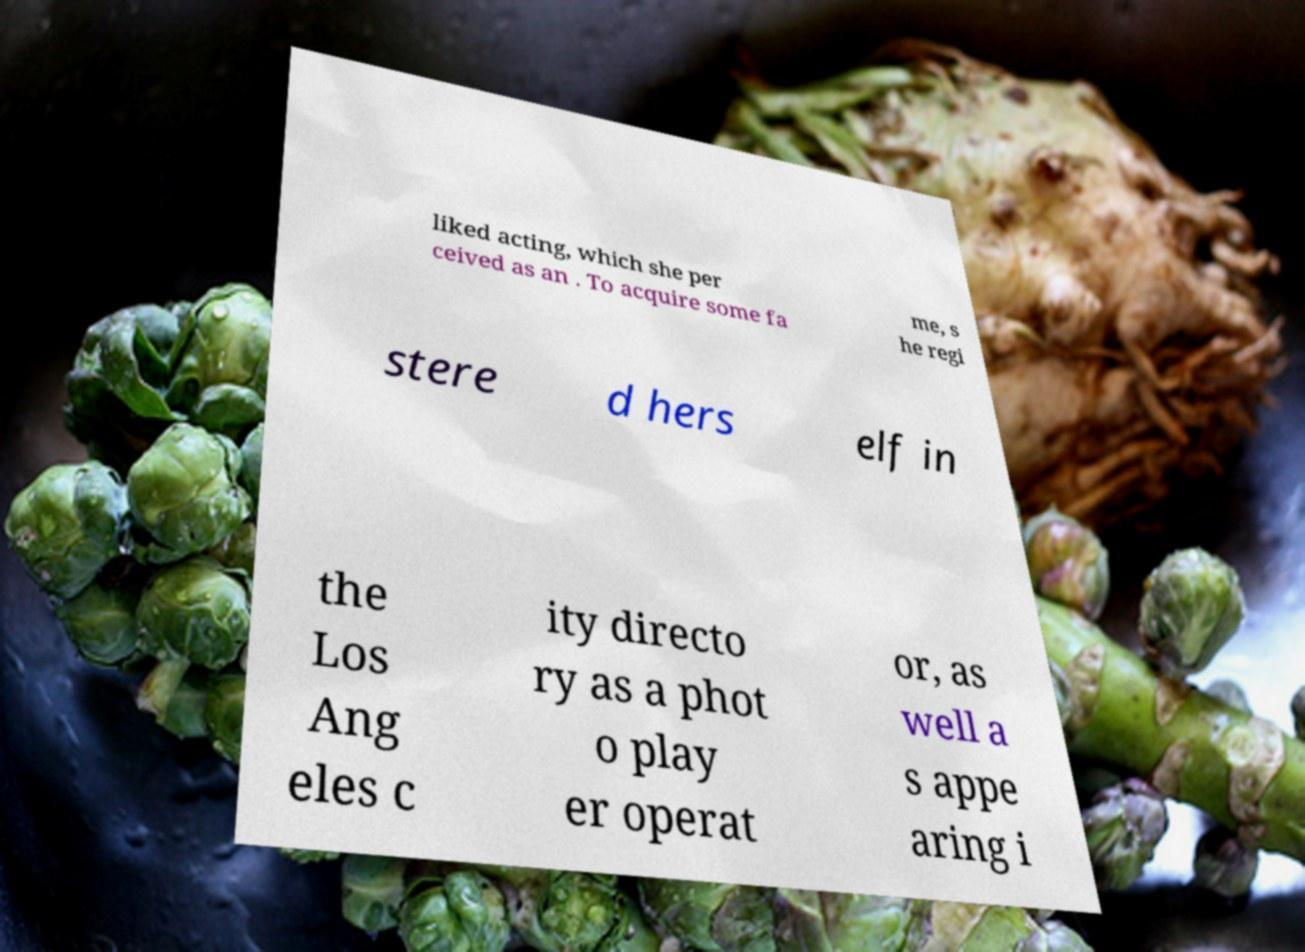Please read and relay the text visible in this image. What does it say? liked acting, which she per ceived as an . To acquire some fa me, s he regi stere d hers elf in the Los Ang eles c ity directo ry as a phot o play er operat or, as well a s appe aring i 